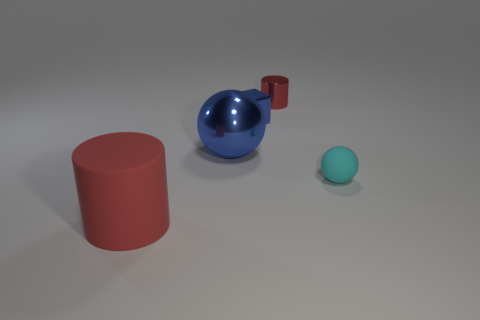Add 2 big objects. How many objects exist? 7 Subtract all blue balls. How many balls are left? 1 Subtract all blocks. How many objects are left? 4 Subtract all blocks. Subtract all tiny red cylinders. How many objects are left? 3 Add 4 red rubber objects. How many red rubber objects are left? 5 Add 2 large green matte balls. How many large green matte balls exist? 2 Subtract 0 purple balls. How many objects are left? 5 Subtract 2 spheres. How many spheres are left? 0 Subtract all cyan blocks. Subtract all red cylinders. How many blocks are left? 1 